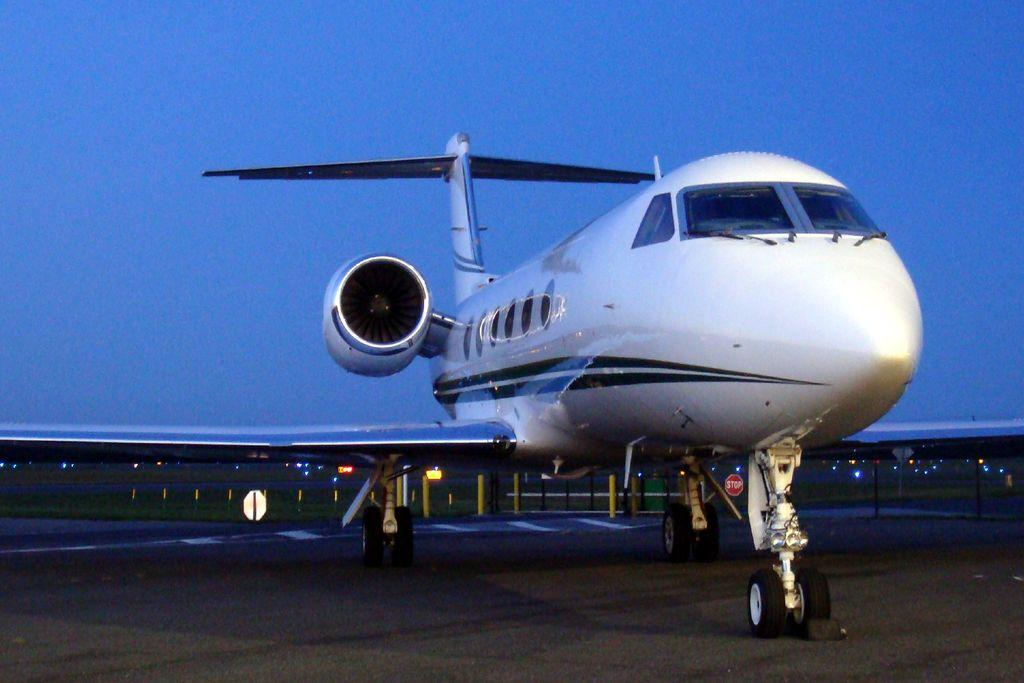What is the main subject of the image? The main subject of the image is an airplane. Where is the airplane located in the image? The airplane is on the ground in the image. What can be seen in the background of the image? In the background of the image, there are poles, a fence, lights, some objects, and the sky. How many babies are sleeping under the quilt in the image? There is no quilt or babies present in the image. What is the airplane wishing for in the image? The image does not depict the airplane having any wishes or desires. 